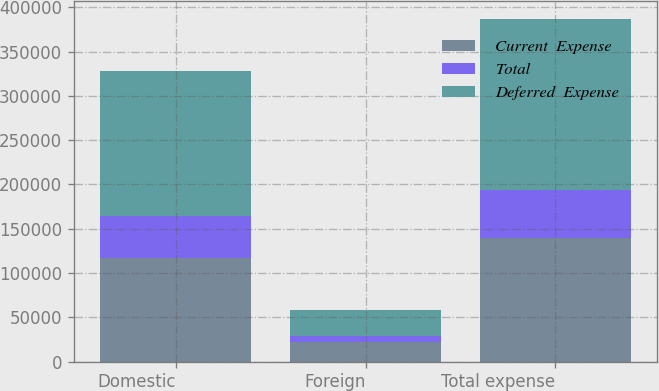<chart> <loc_0><loc_0><loc_500><loc_500><stacked_bar_chart><ecel><fcel>Domestic<fcel>Foreign<fcel>Total expense<nl><fcel>Current  Expense<fcel>116802<fcel>22362<fcel>139164<nl><fcel>Total<fcel>47370<fcel>7053<fcel>54423<nl><fcel>Deferred  Expense<fcel>164172<fcel>29415<fcel>193587<nl></chart> 